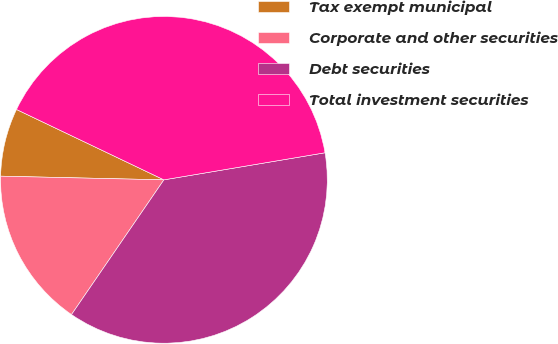Convert chart. <chart><loc_0><loc_0><loc_500><loc_500><pie_chart><fcel>Tax exempt municipal<fcel>Corporate and other securities<fcel>Debt securities<fcel>Total investment securities<nl><fcel>6.73%<fcel>15.79%<fcel>37.22%<fcel>40.26%<nl></chart> 